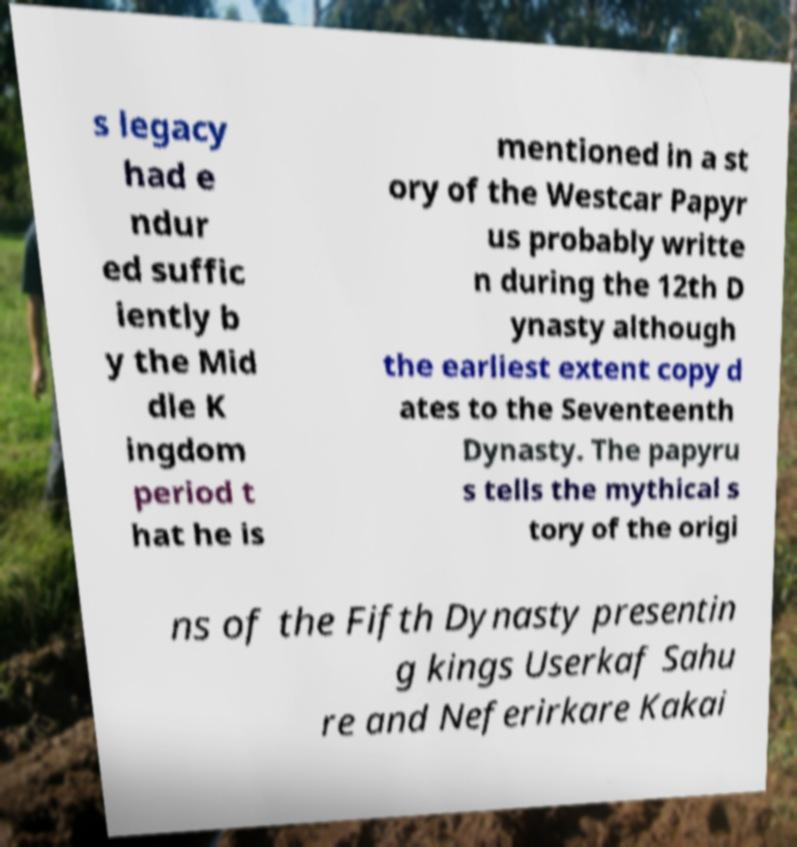Can you accurately transcribe the text from the provided image for me? s legacy had e ndur ed suffic iently b y the Mid dle K ingdom period t hat he is mentioned in a st ory of the Westcar Papyr us probably writte n during the 12th D ynasty although the earliest extent copy d ates to the Seventeenth Dynasty. The papyru s tells the mythical s tory of the origi ns of the Fifth Dynasty presentin g kings Userkaf Sahu re and Neferirkare Kakai 